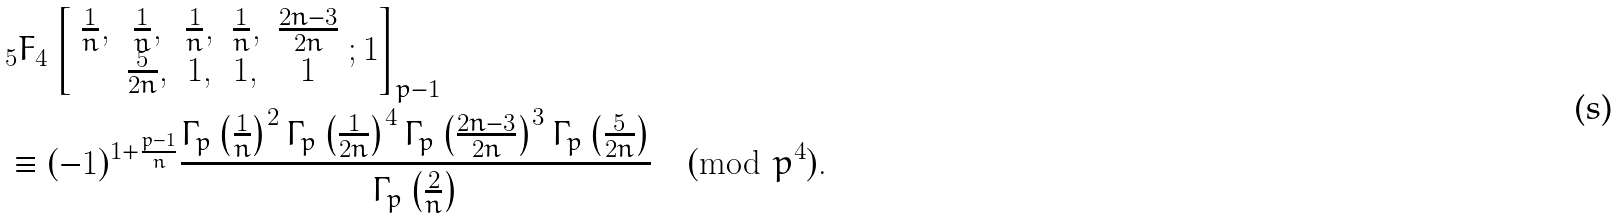Convert formula to latex. <formula><loc_0><loc_0><loc_500><loc_500>& _ { 5 } F _ { 4 } \left [ \begin{array} { c c c c c } \frac { 1 } { n } , & \frac { 1 } { n } , & \frac { 1 } { n } , & \frac { 1 } { n } , & \frac { 2 n - 3 } { 2 n } \\ & \frac { 5 } { 2 n } , & 1 , & 1 , & 1 \end{array} ; 1 \right ] _ { p - 1 } \\ & \equiv ( - 1 ) ^ { 1 + \frac { p - 1 } { n } } \frac { \Gamma _ { p } \left ( \frac { 1 } { n } \right ) ^ { 2 } \Gamma _ { p } \left ( \frac { 1 } { 2 n } \right ) ^ { 4 } \Gamma _ { p } \left ( \frac { 2 n - 3 } { 2 n } \right ) ^ { 3 } \Gamma _ { p } \left ( \frac { 5 } { 2 n } \right ) } { \Gamma _ { p } \left ( \frac { 2 } { n } \right ) } \pmod { p ^ { 4 } } .</formula> 